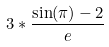Convert formula to latex. <formula><loc_0><loc_0><loc_500><loc_500>3 * \frac { \sin ( \pi ) - 2 } { e }</formula> 